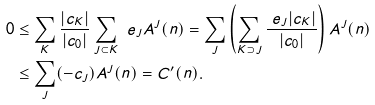<formula> <loc_0><loc_0><loc_500><loc_500>0 & \leq \sum _ { K } \frac { | c _ { K } | } { | c _ { 0 } | } \sum _ { J \subset K } \ e _ { J } A ^ { J } ( n ) = \sum _ { J } \left ( \sum _ { K \supset J } \frac { \ e _ { J } | c _ { K } | } { | c _ { 0 } | } \right ) A ^ { J } ( n ) \\ & \leq \sum _ { J } ( - c _ { J } ) A ^ { J } ( n ) = C ^ { \prime } ( n ) .</formula> 